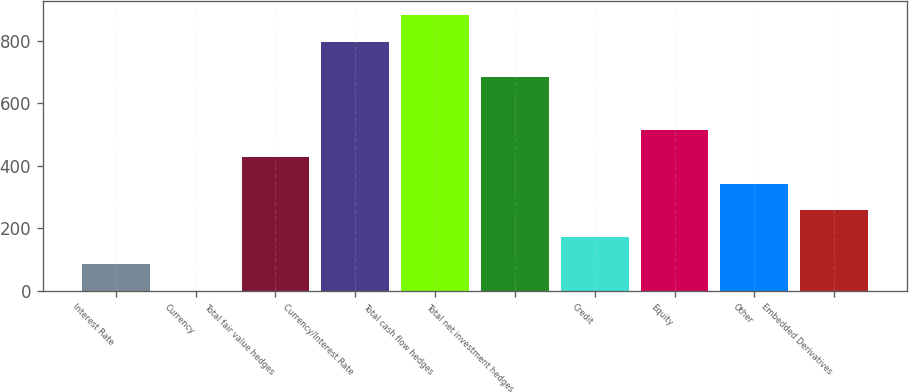Convert chart to OTSL. <chart><loc_0><loc_0><loc_500><loc_500><bar_chart><fcel>Interest Rate<fcel>Currency<fcel>Total fair value hedges<fcel>Currency/Interest Rate<fcel>Total cash flow hedges<fcel>Total net investment hedges<fcel>Credit<fcel>Equity<fcel>Other<fcel>Embedded Derivatives<nl><fcel>86.18<fcel>0.64<fcel>428.34<fcel>798<fcel>883.54<fcel>684.96<fcel>171.72<fcel>513.88<fcel>342.8<fcel>257.26<nl></chart> 